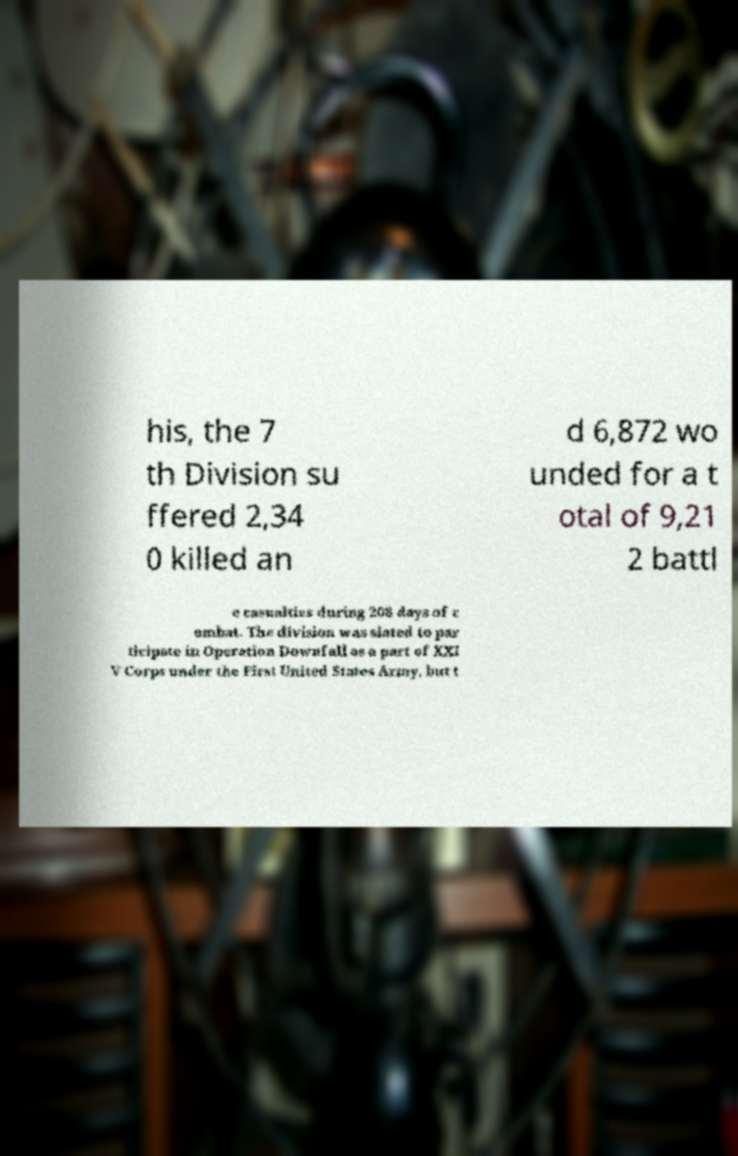Please identify and transcribe the text found in this image. his, the 7 th Division su ffered 2,34 0 killed an d 6,872 wo unded for a t otal of 9,21 2 battl e casualties during 208 days of c ombat. The division was slated to par ticipate in Operation Downfall as a part of XXI V Corps under the First United States Army, but t 